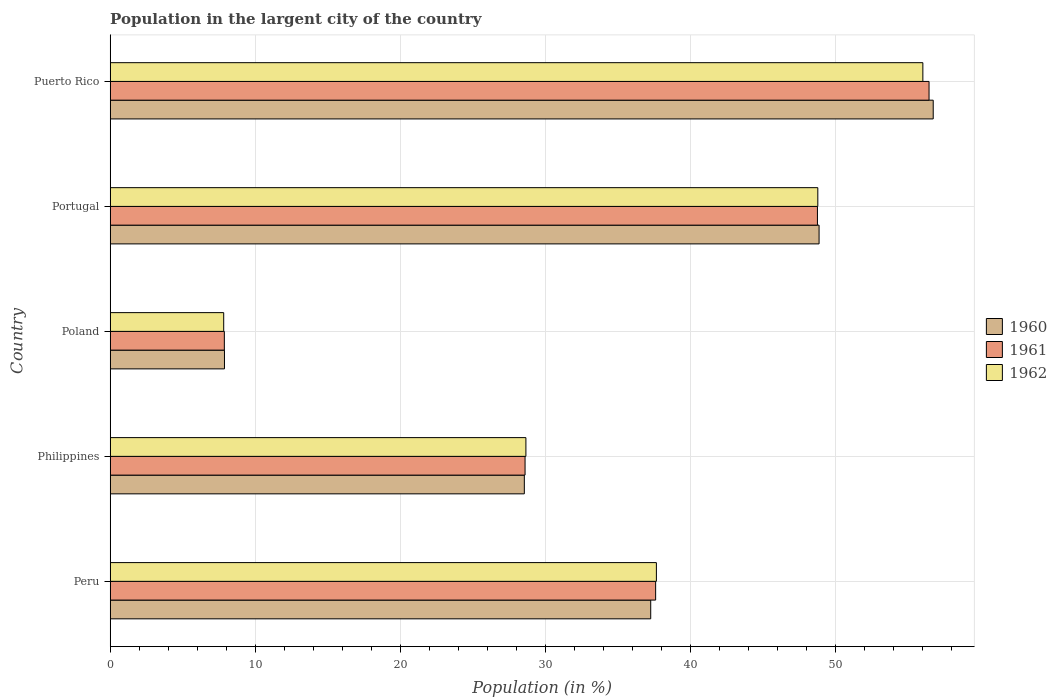How many groups of bars are there?
Offer a terse response. 5. Are the number of bars per tick equal to the number of legend labels?
Your response must be concise. Yes. Are the number of bars on each tick of the Y-axis equal?
Give a very brief answer. Yes. How many bars are there on the 4th tick from the top?
Give a very brief answer. 3. How many bars are there on the 1st tick from the bottom?
Make the answer very short. 3. In how many cases, is the number of bars for a given country not equal to the number of legend labels?
Give a very brief answer. 0. What is the percentage of population in the largent city in 1962 in Philippines?
Offer a very short reply. 28.67. Across all countries, what is the maximum percentage of population in the largent city in 1961?
Your response must be concise. 56.48. Across all countries, what is the minimum percentage of population in the largent city in 1962?
Keep it short and to the point. 7.83. In which country was the percentage of population in the largent city in 1961 maximum?
Keep it short and to the point. Puerto Rico. In which country was the percentage of population in the largent city in 1961 minimum?
Your answer should be compact. Poland. What is the total percentage of population in the largent city in 1961 in the graph?
Your answer should be very brief. 179.37. What is the difference between the percentage of population in the largent city in 1960 in Poland and that in Puerto Rico?
Provide a short and direct response. -48.88. What is the difference between the percentage of population in the largent city in 1960 in Peru and the percentage of population in the largent city in 1961 in Puerto Rico?
Make the answer very short. -19.2. What is the average percentage of population in the largent city in 1961 per country?
Provide a short and direct response. 35.87. What is the difference between the percentage of population in the largent city in 1962 and percentage of population in the largent city in 1960 in Philippines?
Provide a succinct answer. 0.11. In how many countries, is the percentage of population in the largent city in 1961 greater than 16 %?
Provide a succinct answer. 4. What is the ratio of the percentage of population in the largent city in 1960 in Philippines to that in Portugal?
Make the answer very short. 0.58. Is the percentage of population in the largent city in 1961 in Poland less than that in Puerto Rico?
Your response must be concise. Yes. Is the difference between the percentage of population in the largent city in 1962 in Peru and Philippines greater than the difference between the percentage of population in the largent city in 1960 in Peru and Philippines?
Your response must be concise. Yes. What is the difference between the highest and the second highest percentage of population in the largent city in 1960?
Make the answer very short. 7.87. What is the difference between the highest and the lowest percentage of population in the largent city in 1961?
Offer a very short reply. 48.6. In how many countries, is the percentage of population in the largent city in 1962 greater than the average percentage of population in the largent city in 1962 taken over all countries?
Give a very brief answer. 3. Is the sum of the percentage of population in the largent city in 1961 in Philippines and Poland greater than the maximum percentage of population in the largent city in 1962 across all countries?
Ensure brevity in your answer.  No. What does the 1st bar from the top in Philippines represents?
Give a very brief answer. 1962. What does the 1st bar from the bottom in Philippines represents?
Give a very brief answer. 1960. Is it the case that in every country, the sum of the percentage of population in the largent city in 1961 and percentage of population in the largent city in 1962 is greater than the percentage of population in the largent city in 1960?
Keep it short and to the point. Yes. Are all the bars in the graph horizontal?
Your answer should be compact. Yes. How many countries are there in the graph?
Provide a short and direct response. 5. Where does the legend appear in the graph?
Your answer should be very brief. Center right. What is the title of the graph?
Give a very brief answer. Population in the largent city of the country. Does "1985" appear as one of the legend labels in the graph?
Ensure brevity in your answer.  No. What is the label or title of the Y-axis?
Provide a succinct answer. Country. What is the Population (in %) in 1960 in Peru?
Your response must be concise. 37.28. What is the Population (in %) in 1961 in Peru?
Give a very brief answer. 37.62. What is the Population (in %) of 1962 in Peru?
Your answer should be very brief. 37.67. What is the Population (in %) of 1960 in Philippines?
Your answer should be compact. 28.56. What is the Population (in %) in 1961 in Philippines?
Give a very brief answer. 28.62. What is the Population (in %) in 1962 in Philippines?
Provide a short and direct response. 28.67. What is the Population (in %) in 1960 in Poland?
Provide a succinct answer. 7.88. What is the Population (in %) in 1961 in Poland?
Provide a succinct answer. 7.88. What is the Population (in %) of 1962 in Poland?
Make the answer very short. 7.83. What is the Population (in %) of 1960 in Portugal?
Keep it short and to the point. 48.89. What is the Population (in %) of 1961 in Portugal?
Keep it short and to the point. 48.78. What is the Population (in %) of 1962 in Portugal?
Your answer should be very brief. 48.81. What is the Population (in %) in 1960 in Puerto Rico?
Make the answer very short. 56.77. What is the Population (in %) of 1961 in Puerto Rico?
Your answer should be compact. 56.48. What is the Population (in %) of 1962 in Puerto Rico?
Give a very brief answer. 56.05. Across all countries, what is the maximum Population (in %) of 1960?
Your answer should be very brief. 56.77. Across all countries, what is the maximum Population (in %) of 1961?
Offer a terse response. 56.48. Across all countries, what is the maximum Population (in %) in 1962?
Keep it short and to the point. 56.05. Across all countries, what is the minimum Population (in %) of 1960?
Provide a short and direct response. 7.88. Across all countries, what is the minimum Population (in %) of 1961?
Provide a short and direct response. 7.88. Across all countries, what is the minimum Population (in %) of 1962?
Offer a terse response. 7.83. What is the total Population (in %) of 1960 in the graph?
Provide a short and direct response. 179.39. What is the total Population (in %) in 1961 in the graph?
Provide a short and direct response. 179.37. What is the total Population (in %) of 1962 in the graph?
Ensure brevity in your answer.  179.04. What is the difference between the Population (in %) in 1960 in Peru and that in Philippines?
Your response must be concise. 8.72. What is the difference between the Population (in %) in 1961 in Peru and that in Philippines?
Provide a succinct answer. 9.01. What is the difference between the Population (in %) of 1962 in Peru and that in Philippines?
Ensure brevity in your answer.  9. What is the difference between the Population (in %) in 1960 in Peru and that in Poland?
Your response must be concise. 29.4. What is the difference between the Population (in %) of 1961 in Peru and that in Poland?
Ensure brevity in your answer.  29.75. What is the difference between the Population (in %) of 1962 in Peru and that in Poland?
Your response must be concise. 29.84. What is the difference between the Population (in %) in 1960 in Peru and that in Portugal?
Offer a very short reply. -11.61. What is the difference between the Population (in %) of 1961 in Peru and that in Portugal?
Your answer should be compact. -11.16. What is the difference between the Population (in %) of 1962 in Peru and that in Portugal?
Your response must be concise. -11.13. What is the difference between the Population (in %) of 1960 in Peru and that in Puerto Rico?
Your answer should be very brief. -19.48. What is the difference between the Population (in %) in 1961 in Peru and that in Puerto Rico?
Make the answer very short. -18.86. What is the difference between the Population (in %) in 1962 in Peru and that in Puerto Rico?
Your answer should be compact. -18.38. What is the difference between the Population (in %) of 1960 in Philippines and that in Poland?
Ensure brevity in your answer.  20.68. What is the difference between the Population (in %) in 1961 in Philippines and that in Poland?
Ensure brevity in your answer.  20.74. What is the difference between the Population (in %) of 1962 in Philippines and that in Poland?
Your answer should be very brief. 20.84. What is the difference between the Population (in %) in 1960 in Philippines and that in Portugal?
Your response must be concise. -20.33. What is the difference between the Population (in %) of 1961 in Philippines and that in Portugal?
Make the answer very short. -20.16. What is the difference between the Population (in %) of 1962 in Philippines and that in Portugal?
Offer a terse response. -20.13. What is the difference between the Population (in %) of 1960 in Philippines and that in Puerto Rico?
Make the answer very short. -28.2. What is the difference between the Population (in %) in 1961 in Philippines and that in Puerto Rico?
Keep it short and to the point. -27.86. What is the difference between the Population (in %) in 1962 in Philippines and that in Puerto Rico?
Offer a very short reply. -27.38. What is the difference between the Population (in %) of 1960 in Poland and that in Portugal?
Offer a terse response. -41.01. What is the difference between the Population (in %) in 1961 in Poland and that in Portugal?
Offer a terse response. -40.91. What is the difference between the Population (in %) in 1962 in Poland and that in Portugal?
Provide a short and direct response. -40.97. What is the difference between the Population (in %) in 1960 in Poland and that in Puerto Rico?
Give a very brief answer. -48.88. What is the difference between the Population (in %) of 1961 in Poland and that in Puerto Rico?
Give a very brief answer. -48.6. What is the difference between the Population (in %) in 1962 in Poland and that in Puerto Rico?
Your response must be concise. -48.22. What is the difference between the Population (in %) in 1960 in Portugal and that in Puerto Rico?
Your answer should be very brief. -7.87. What is the difference between the Population (in %) of 1961 in Portugal and that in Puerto Rico?
Keep it short and to the point. -7.7. What is the difference between the Population (in %) of 1962 in Portugal and that in Puerto Rico?
Keep it short and to the point. -7.24. What is the difference between the Population (in %) of 1960 in Peru and the Population (in %) of 1961 in Philippines?
Offer a terse response. 8.67. What is the difference between the Population (in %) of 1960 in Peru and the Population (in %) of 1962 in Philippines?
Your response must be concise. 8.61. What is the difference between the Population (in %) in 1961 in Peru and the Population (in %) in 1962 in Philippines?
Ensure brevity in your answer.  8.95. What is the difference between the Population (in %) of 1960 in Peru and the Population (in %) of 1961 in Poland?
Make the answer very short. 29.41. What is the difference between the Population (in %) of 1960 in Peru and the Population (in %) of 1962 in Poland?
Keep it short and to the point. 29.45. What is the difference between the Population (in %) of 1961 in Peru and the Population (in %) of 1962 in Poland?
Make the answer very short. 29.79. What is the difference between the Population (in %) in 1960 in Peru and the Population (in %) in 1961 in Portugal?
Offer a terse response. -11.5. What is the difference between the Population (in %) of 1960 in Peru and the Population (in %) of 1962 in Portugal?
Provide a succinct answer. -11.53. What is the difference between the Population (in %) of 1961 in Peru and the Population (in %) of 1962 in Portugal?
Make the answer very short. -11.18. What is the difference between the Population (in %) in 1960 in Peru and the Population (in %) in 1961 in Puerto Rico?
Provide a succinct answer. -19.2. What is the difference between the Population (in %) in 1960 in Peru and the Population (in %) in 1962 in Puerto Rico?
Make the answer very short. -18.77. What is the difference between the Population (in %) in 1961 in Peru and the Population (in %) in 1962 in Puerto Rico?
Give a very brief answer. -18.43. What is the difference between the Population (in %) in 1960 in Philippines and the Population (in %) in 1961 in Poland?
Offer a very short reply. 20.69. What is the difference between the Population (in %) of 1960 in Philippines and the Population (in %) of 1962 in Poland?
Make the answer very short. 20.73. What is the difference between the Population (in %) of 1961 in Philippines and the Population (in %) of 1962 in Poland?
Provide a short and direct response. 20.78. What is the difference between the Population (in %) of 1960 in Philippines and the Population (in %) of 1961 in Portugal?
Your response must be concise. -20.22. What is the difference between the Population (in %) of 1960 in Philippines and the Population (in %) of 1962 in Portugal?
Give a very brief answer. -20.24. What is the difference between the Population (in %) in 1961 in Philippines and the Population (in %) in 1962 in Portugal?
Offer a terse response. -20.19. What is the difference between the Population (in %) of 1960 in Philippines and the Population (in %) of 1961 in Puerto Rico?
Your response must be concise. -27.91. What is the difference between the Population (in %) in 1960 in Philippines and the Population (in %) in 1962 in Puerto Rico?
Ensure brevity in your answer.  -27.49. What is the difference between the Population (in %) in 1961 in Philippines and the Population (in %) in 1962 in Puerto Rico?
Ensure brevity in your answer.  -27.43. What is the difference between the Population (in %) of 1960 in Poland and the Population (in %) of 1961 in Portugal?
Provide a succinct answer. -40.9. What is the difference between the Population (in %) in 1960 in Poland and the Population (in %) in 1962 in Portugal?
Make the answer very short. -40.92. What is the difference between the Population (in %) in 1961 in Poland and the Population (in %) in 1962 in Portugal?
Provide a short and direct response. -40.93. What is the difference between the Population (in %) in 1960 in Poland and the Population (in %) in 1961 in Puerto Rico?
Give a very brief answer. -48.59. What is the difference between the Population (in %) of 1960 in Poland and the Population (in %) of 1962 in Puerto Rico?
Ensure brevity in your answer.  -48.17. What is the difference between the Population (in %) in 1961 in Poland and the Population (in %) in 1962 in Puerto Rico?
Keep it short and to the point. -48.18. What is the difference between the Population (in %) of 1960 in Portugal and the Population (in %) of 1961 in Puerto Rico?
Your response must be concise. -7.58. What is the difference between the Population (in %) in 1960 in Portugal and the Population (in %) in 1962 in Puerto Rico?
Ensure brevity in your answer.  -7.16. What is the difference between the Population (in %) of 1961 in Portugal and the Population (in %) of 1962 in Puerto Rico?
Your answer should be compact. -7.27. What is the average Population (in %) in 1960 per country?
Give a very brief answer. 35.88. What is the average Population (in %) of 1961 per country?
Provide a succinct answer. 35.87. What is the average Population (in %) in 1962 per country?
Provide a succinct answer. 35.81. What is the difference between the Population (in %) in 1960 and Population (in %) in 1961 in Peru?
Keep it short and to the point. -0.34. What is the difference between the Population (in %) in 1960 and Population (in %) in 1962 in Peru?
Your response must be concise. -0.39. What is the difference between the Population (in %) in 1961 and Population (in %) in 1962 in Peru?
Ensure brevity in your answer.  -0.05. What is the difference between the Population (in %) in 1960 and Population (in %) in 1961 in Philippines?
Your answer should be compact. -0.05. What is the difference between the Population (in %) of 1960 and Population (in %) of 1962 in Philippines?
Provide a succinct answer. -0.11. What is the difference between the Population (in %) in 1961 and Population (in %) in 1962 in Philippines?
Ensure brevity in your answer.  -0.06. What is the difference between the Population (in %) in 1960 and Population (in %) in 1961 in Poland?
Make the answer very short. 0.01. What is the difference between the Population (in %) of 1960 and Population (in %) of 1962 in Poland?
Keep it short and to the point. 0.05. What is the difference between the Population (in %) of 1961 and Population (in %) of 1962 in Poland?
Your response must be concise. 0.04. What is the difference between the Population (in %) in 1960 and Population (in %) in 1961 in Portugal?
Your response must be concise. 0.11. What is the difference between the Population (in %) in 1960 and Population (in %) in 1962 in Portugal?
Provide a short and direct response. 0.09. What is the difference between the Population (in %) in 1961 and Population (in %) in 1962 in Portugal?
Ensure brevity in your answer.  -0.03. What is the difference between the Population (in %) in 1960 and Population (in %) in 1961 in Puerto Rico?
Your response must be concise. 0.29. What is the difference between the Population (in %) in 1960 and Population (in %) in 1962 in Puerto Rico?
Your response must be concise. 0.71. What is the difference between the Population (in %) of 1961 and Population (in %) of 1962 in Puerto Rico?
Offer a very short reply. 0.43. What is the ratio of the Population (in %) of 1960 in Peru to that in Philippines?
Keep it short and to the point. 1.31. What is the ratio of the Population (in %) of 1961 in Peru to that in Philippines?
Your answer should be very brief. 1.31. What is the ratio of the Population (in %) of 1962 in Peru to that in Philippines?
Your answer should be compact. 1.31. What is the ratio of the Population (in %) of 1960 in Peru to that in Poland?
Offer a terse response. 4.73. What is the ratio of the Population (in %) of 1961 in Peru to that in Poland?
Your answer should be very brief. 4.78. What is the ratio of the Population (in %) of 1962 in Peru to that in Poland?
Keep it short and to the point. 4.81. What is the ratio of the Population (in %) of 1960 in Peru to that in Portugal?
Your answer should be compact. 0.76. What is the ratio of the Population (in %) of 1961 in Peru to that in Portugal?
Ensure brevity in your answer.  0.77. What is the ratio of the Population (in %) of 1962 in Peru to that in Portugal?
Your answer should be compact. 0.77. What is the ratio of the Population (in %) in 1960 in Peru to that in Puerto Rico?
Offer a terse response. 0.66. What is the ratio of the Population (in %) of 1961 in Peru to that in Puerto Rico?
Your response must be concise. 0.67. What is the ratio of the Population (in %) in 1962 in Peru to that in Puerto Rico?
Your response must be concise. 0.67. What is the ratio of the Population (in %) in 1960 in Philippines to that in Poland?
Provide a short and direct response. 3.62. What is the ratio of the Population (in %) of 1961 in Philippines to that in Poland?
Your response must be concise. 3.63. What is the ratio of the Population (in %) in 1962 in Philippines to that in Poland?
Offer a terse response. 3.66. What is the ratio of the Population (in %) of 1960 in Philippines to that in Portugal?
Ensure brevity in your answer.  0.58. What is the ratio of the Population (in %) of 1961 in Philippines to that in Portugal?
Offer a very short reply. 0.59. What is the ratio of the Population (in %) of 1962 in Philippines to that in Portugal?
Provide a short and direct response. 0.59. What is the ratio of the Population (in %) in 1960 in Philippines to that in Puerto Rico?
Provide a short and direct response. 0.5. What is the ratio of the Population (in %) in 1961 in Philippines to that in Puerto Rico?
Ensure brevity in your answer.  0.51. What is the ratio of the Population (in %) of 1962 in Philippines to that in Puerto Rico?
Offer a very short reply. 0.51. What is the ratio of the Population (in %) in 1960 in Poland to that in Portugal?
Make the answer very short. 0.16. What is the ratio of the Population (in %) in 1961 in Poland to that in Portugal?
Offer a terse response. 0.16. What is the ratio of the Population (in %) in 1962 in Poland to that in Portugal?
Offer a very short reply. 0.16. What is the ratio of the Population (in %) in 1960 in Poland to that in Puerto Rico?
Ensure brevity in your answer.  0.14. What is the ratio of the Population (in %) of 1961 in Poland to that in Puerto Rico?
Provide a succinct answer. 0.14. What is the ratio of the Population (in %) in 1962 in Poland to that in Puerto Rico?
Ensure brevity in your answer.  0.14. What is the ratio of the Population (in %) in 1960 in Portugal to that in Puerto Rico?
Keep it short and to the point. 0.86. What is the ratio of the Population (in %) in 1961 in Portugal to that in Puerto Rico?
Offer a terse response. 0.86. What is the ratio of the Population (in %) in 1962 in Portugal to that in Puerto Rico?
Offer a very short reply. 0.87. What is the difference between the highest and the second highest Population (in %) of 1960?
Provide a succinct answer. 7.87. What is the difference between the highest and the second highest Population (in %) in 1961?
Your answer should be very brief. 7.7. What is the difference between the highest and the second highest Population (in %) of 1962?
Your response must be concise. 7.24. What is the difference between the highest and the lowest Population (in %) of 1960?
Offer a very short reply. 48.88. What is the difference between the highest and the lowest Population (in %) in 1961?
Keep it short and to the point. 48.6. What is the difference between the highest and the lowest Population (in %) in 1962?
Your answer should be compact. 48.22. 